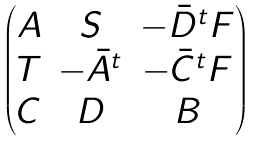<formula> <loc_0><loc_0><loc_500><loc_500>\begin{pmatrix} A & S & - \bar { D } ^ { t } F \\ T & - \bar { A } ^ { t } & - \bar { C } ^ { t } F \\ C & D & B \end{pmatrix}</formula> 